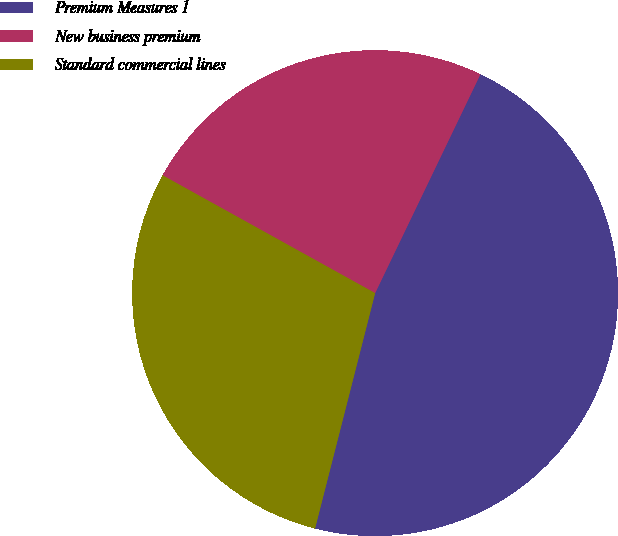<chart> <loc_0><loc_0><loc_500><loc_500><pie_chart><fcel>Premium Measures 1<fcel>New business premium<fcel>Standard commercial lines<nl><fcel>46.84%<fcel>24.08%<fcel>29.08%<nl></chart> 